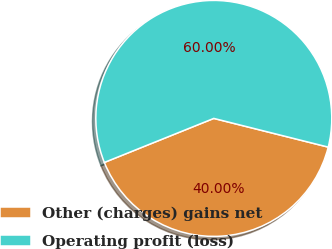Convert chart. <chart><loc_0><loc_0><loc_500><loc_500><pie_chart><fcel>Other (charges) gains net<fcel>Operating profit (loss)<nl><fcel>40.0%<fcel>60.0%<nl></chart> 